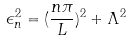Convert formula to latex. <formula><loc_0><loc_0><loc_500><loc_500>\epsilon _ { n } ^ { 2 } = ( \frac { n \pi } { L } ) ^ { 2 } + \Lambda ^ { 2 }</formula> 